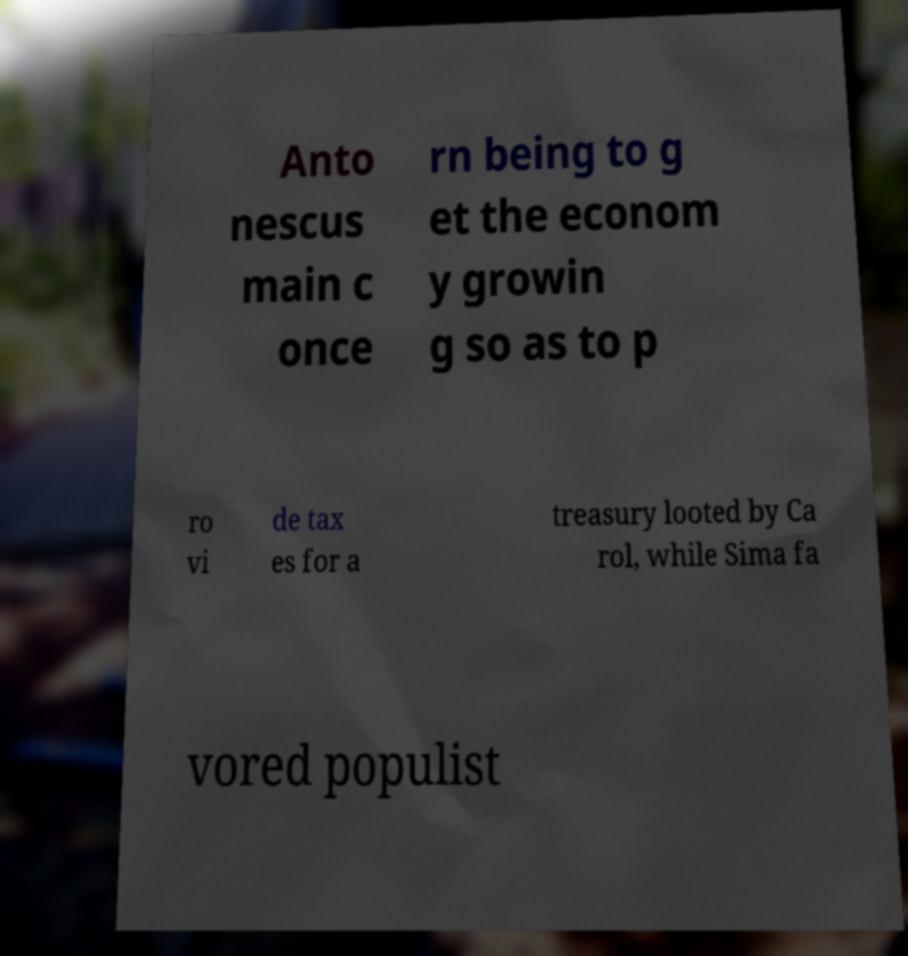Could you extract and type out the text from this image? Anto nescus main c once rn being to g et the econom y growin g so as to p ro vi de tax es for a treasury looted by Ca rol, while Sima fa vored populist 